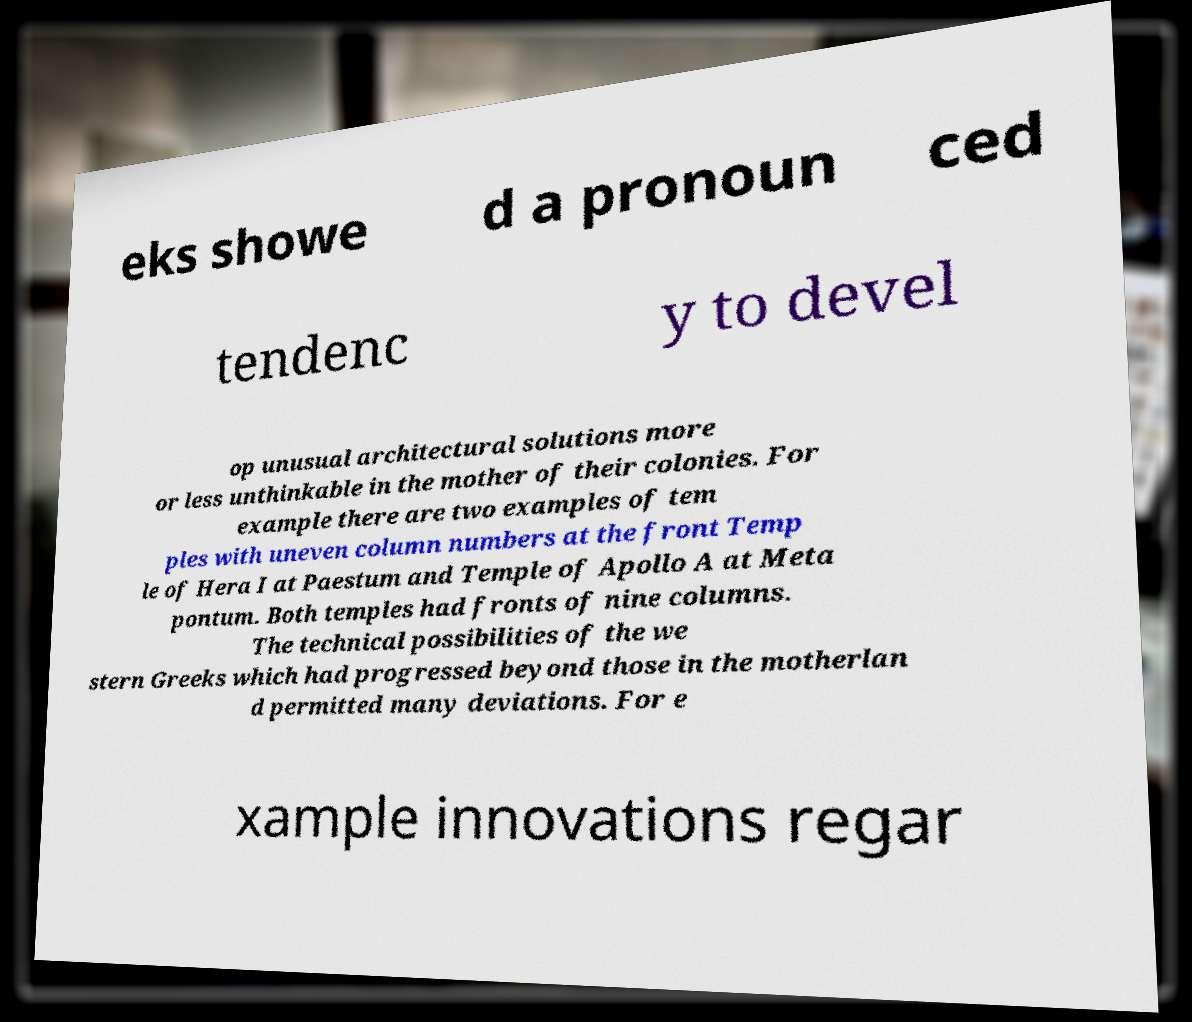Can you read and provide the text displayed in the image?This photo seems to have some interesting text. Can you extract and type it out for me? eks showe d a pronoun ced tendenc y to devel op unusual architectural solutions more or less unthinkable in the mother of their colonies. For example there are two examples of tem ples with uneven column numbers at the front Temp le of Hera I at Paestum and Temple of Apollo A at Meta pontum. Both temples had fronts of nine columns. The technical possibilities of the we stern Greeks which had progressed beyond those in the motherlan d permitted many deviations. For e xample innovations regar 